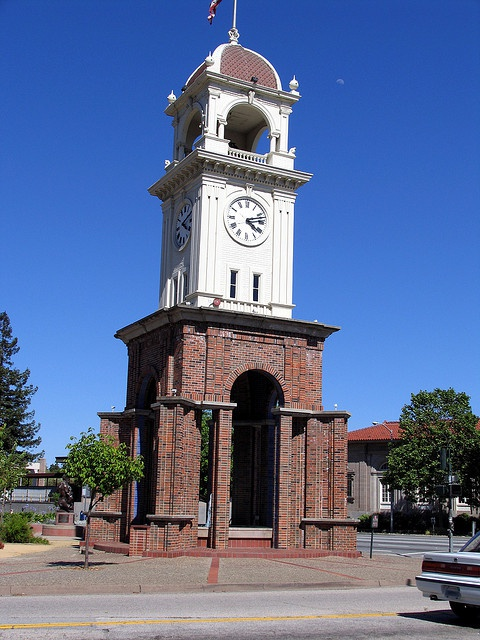Describe the objects in this image and their specific colors. I can see car in blue, black, gray, and lightgray tones, clock in blue, whitesmoke, gray, darkgray, and black tones, and clock in blue, gray, and black tones in this image. 